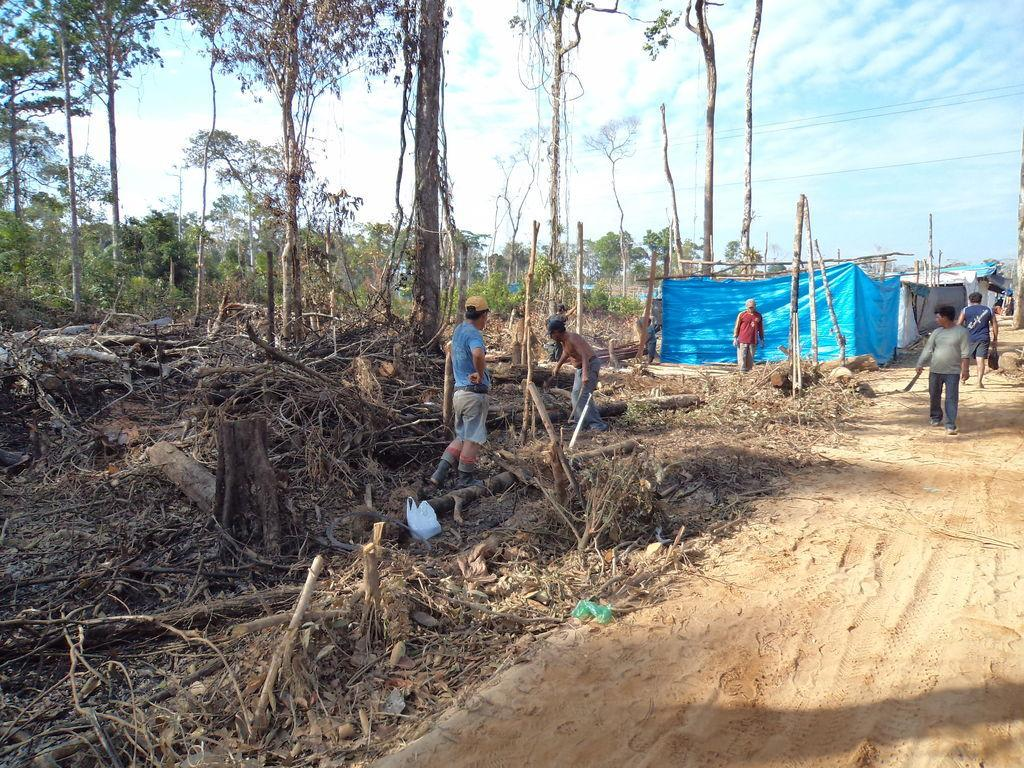What is happening in the image involving people? There is a group of people standing in the image. What natural elements can be seen in the image? Tree trunks, branches, and trees are present in the image. What man-made structures are visible in the image? There are structures that resemble houses in the image. What additional objects can be seen in the image? There are cables in the image. What is visible in the background of the image? The sky is visible in the background of the image. How many times did the person kick the tree trunk in the image? There is no person kicking a tree trunk in the image; it is not present. What is the fifth object in the image? The provided facts do not list objects in a specific order, so there is no "fifth" object in the image. 